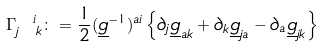<formula> <loc_0><loc_0><loc_500><loc_500>\Gamma _ { j \ k } ^ { \ i } & \colon = \frac { 1 } { 2 } ( \underline { g } ^ { - 1 } ) ^ { a i } \left \{ \partial _ { j } \underline { g } _ { a k } + \partial _ { k } \underline { g } _ { j a } - \partial _ { a } \underline { g } _ { j k } \right \}</formula> 